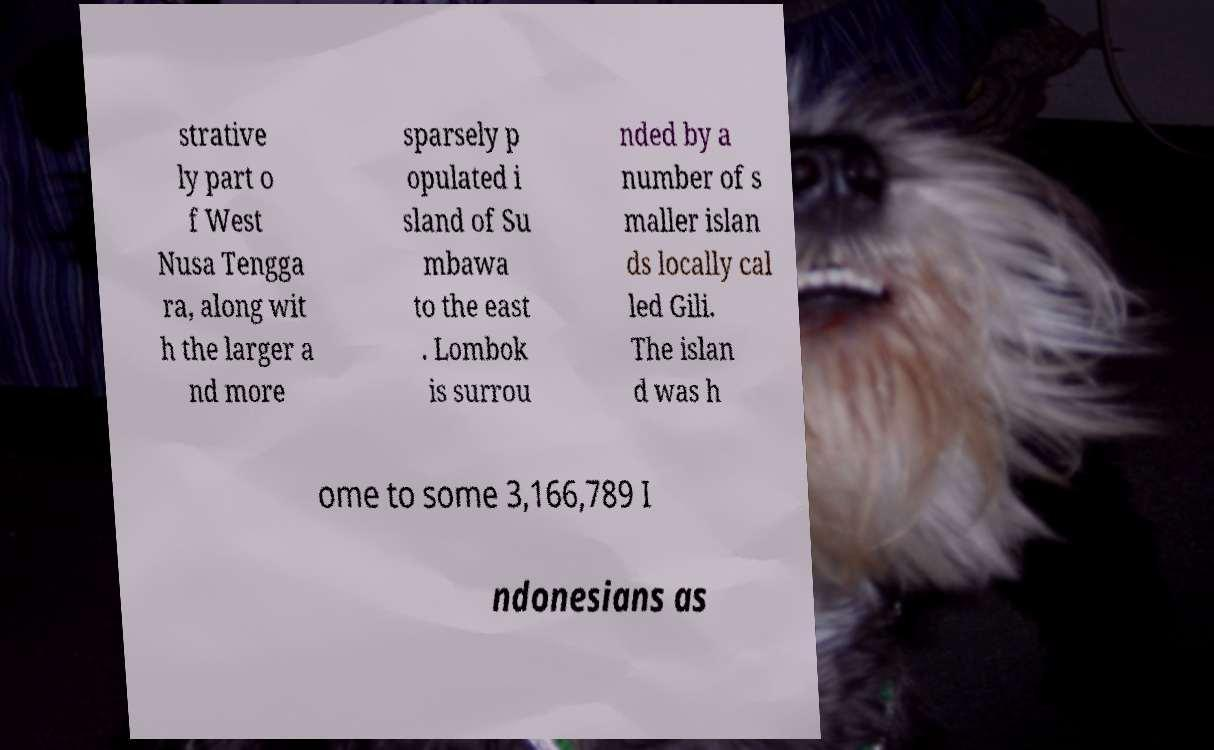Can you accurately transcribe the text from the provided image for me? strative ly part o f West Nusa Tengga ra, along wit h the larger a nd more sparsely p opulated i sland of Su mbawa to the east . Lombok is surrou nded by a number of s maller islan ds locally cal led Gili. The islan d was h ome to some 3,166,789 I ndonesians as 